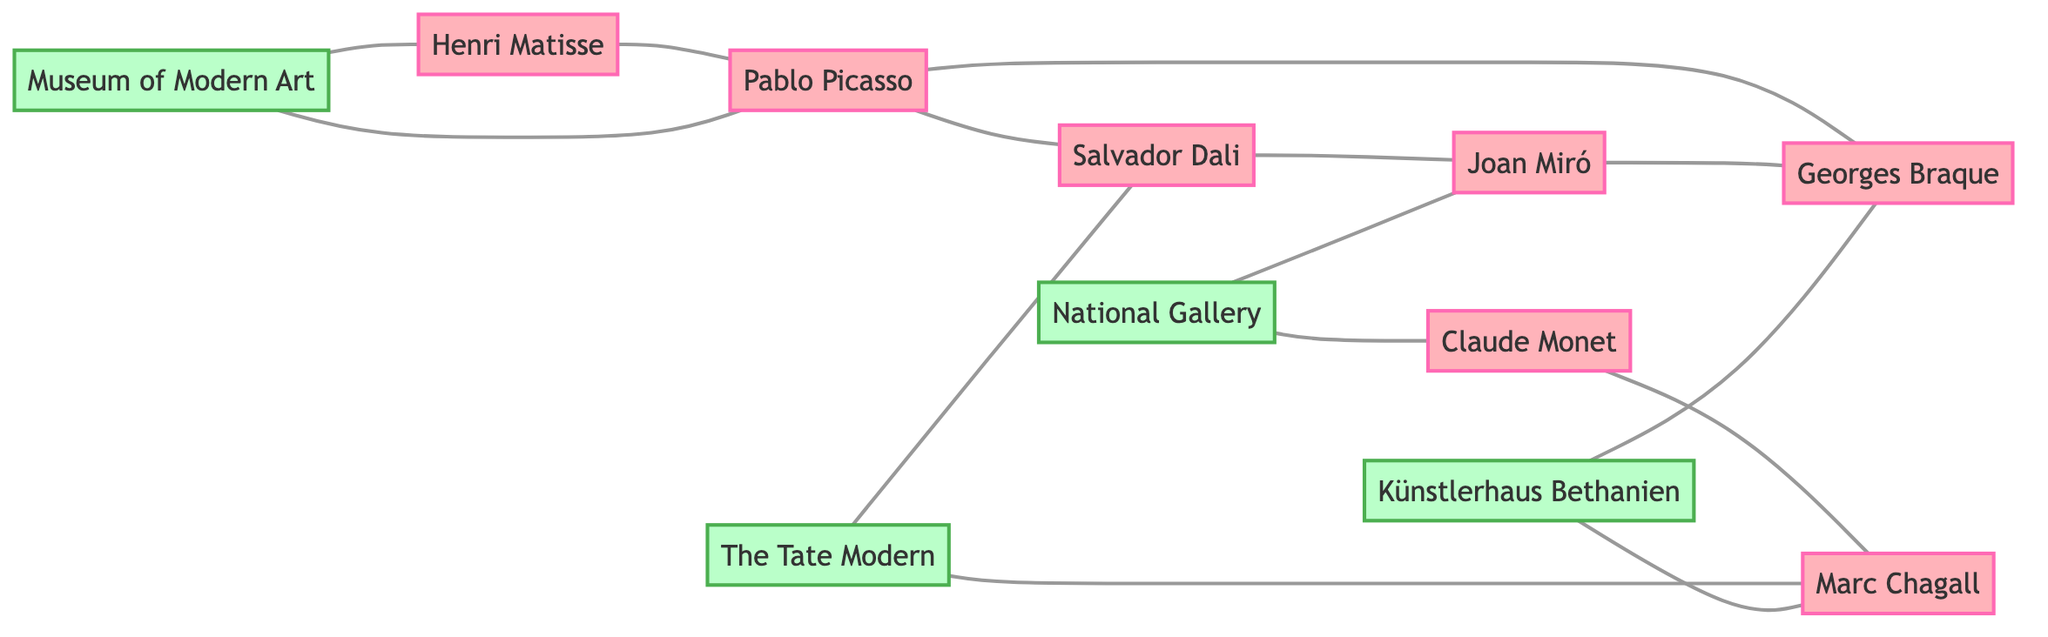What is the total number of artists in the diagram? By counting the nodes labeled as "Artist", we find there are 7 distinct artists listed: Pablo Picasso, Salvador Dali, Henri Matisse, Claude Monet, Marc Chagall, Georges Braque, and Joan Miró.
Answer: 7 Which gallery has displayed Henri Matisse? Looking at the edges connected to the node for Henri Matisse, we see that it is connected to the "Museum of Modern Art", indicating that this gallery has displayed his work.
Answer: Museum of Modern Art How many times is Pablo Picasso represented in connections? Counting the edges connected to the Pablo Picasso node, we see there are 4 edges: to Salvador Dali, Georges Braque, Museum of Modern Art, and Henri Matisse. Hence, Pablo Picasso has 4 connections.
Answer: 4 Name the artists that collaborated with Georges Braque. Checking the edges involving Georges Braque, we see he has collaborated with Joan Miró and has a direct connection through his influence with Pablo Picasso. Thus, the artists are Joan Miró and Pablo Picasso.
Answer: Joan Miró, Pablo Picasso Which artist is a contemporary of Claude Monet? Inspecting the edges associated with Claude Monet, we find a connection to Marc Chagall, indicating that they are contemporaries.
Answer: Marc Chagall What is the relationship type between Salvador Dali and Joan Miró? Examining the edge connecting Salvador Dali to Joan Miró, we observe that they have a "Met" relationship as indicated in the edge description.
Answer: Met Which gallery displayed the most artists based on the diagram? Analyzing the connections from the gallery nodes, we see that the "Museum of Modern Art" has displayed 2 artists (Pablo Picasso and Henri Matisse), while "The Tate Modern" also displayed 2 (Salvador Dali and Marc Chagall). Each gallery has a tie, but "Künstlerhaus Bethanien" and "National Gallery" also only displayed 2 each, thus no gallery stands out.
Answer: Museum of Modern Art, The Tate Modern, Künstlerhaus Bethanien, National Gallery Are there any artists who are not connected to any gallery? Upon reviewing the edges, we see that all artists listed have at least one connection to a gallery; hence, no artists are left without representation.
Answer: No 